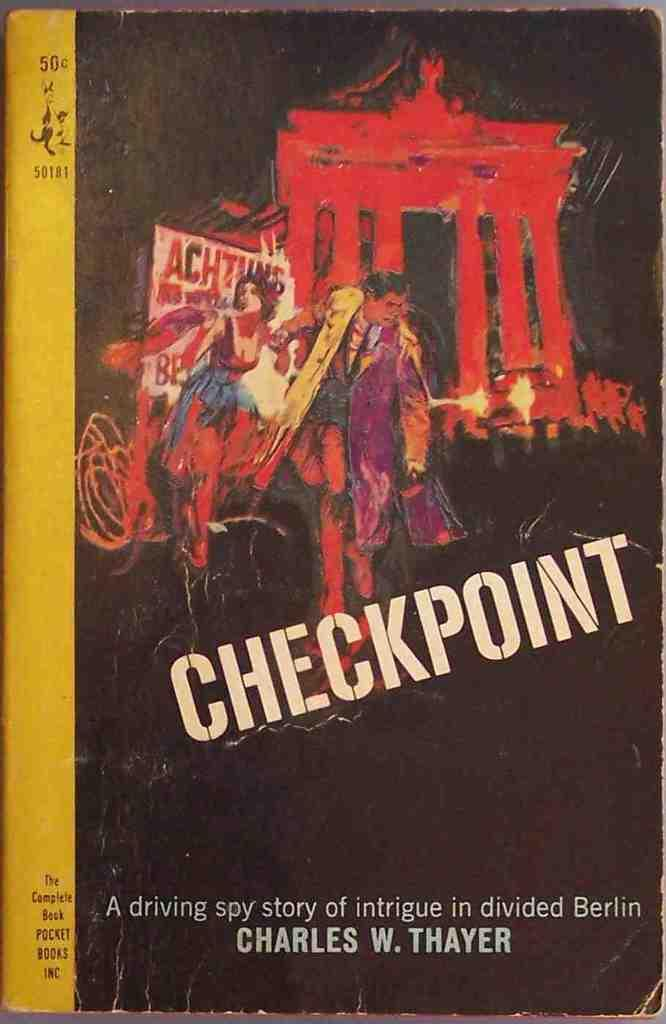<image>
Relay a brief, clear account of the picture shown. A booked titled "Checkpoint" by CHarles W. Thayer. 